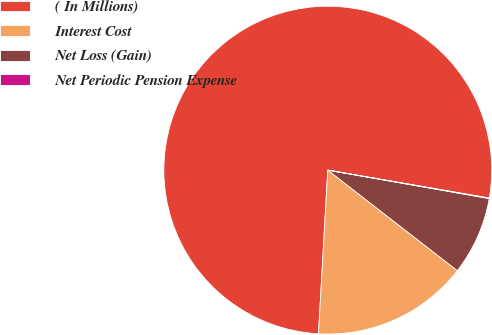Convert chart. <chart><loc_0><loc_0><loc_500><loc_500><pie_chart><fcel>( In Millions)<fcel>Interest Cost<fcel>Net Loss (Gain)<fcel>Net Periodic Pension Expense<nl><fcel>76.82%<fcel>15.4%<fcel>7.73%<fcel>0.05%<nl></chart> 